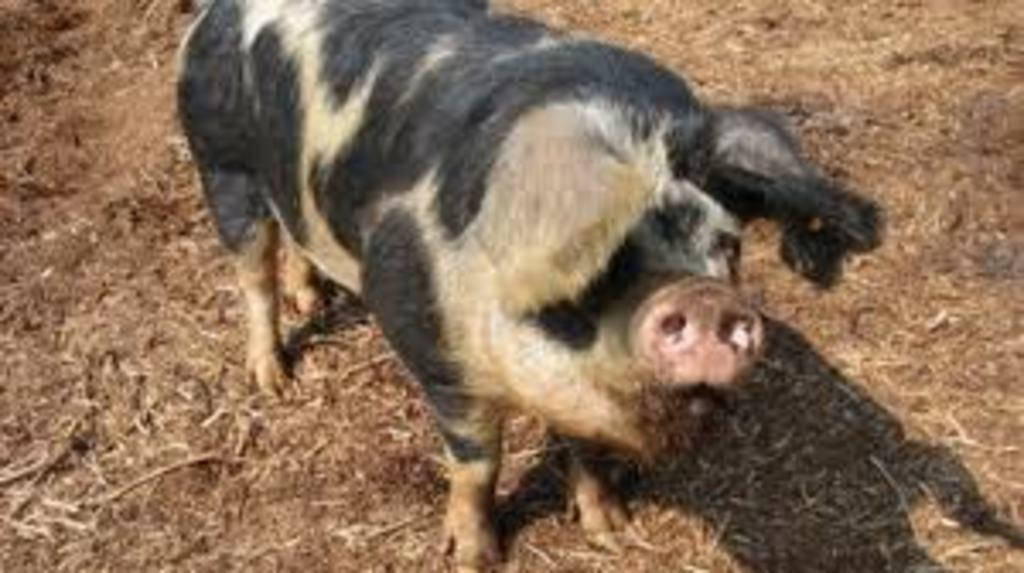What type of animal can be seen in the image? There is an animal in the image that resembles a pig. Can you describe the coloration of the animal? The animal has a white and black coloration. What can be found at the bottom of the image? Twigs and soil are visible at the bottom of the image. Where is the kitty playing with the cannon in the image? There is no kitty or cannon present in the image. What type of club is visible in the image? There is no club present in the image. 